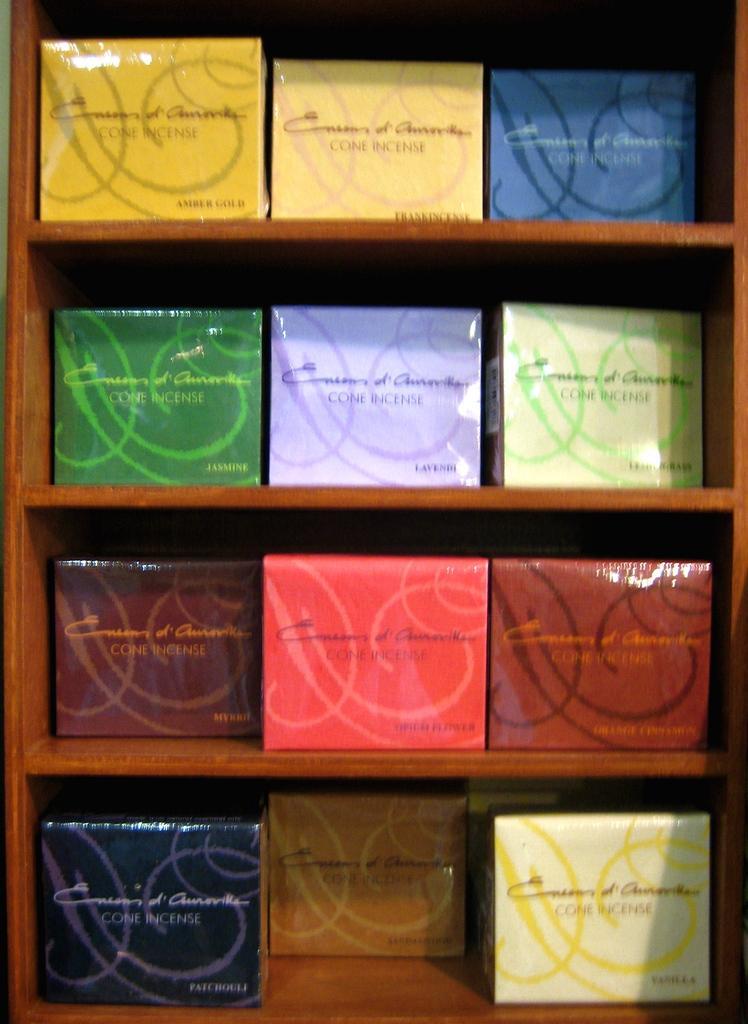Describe this image in one or two sentences. In this picture we can see a rack here, there are some different colors of boxes present on this rack. 